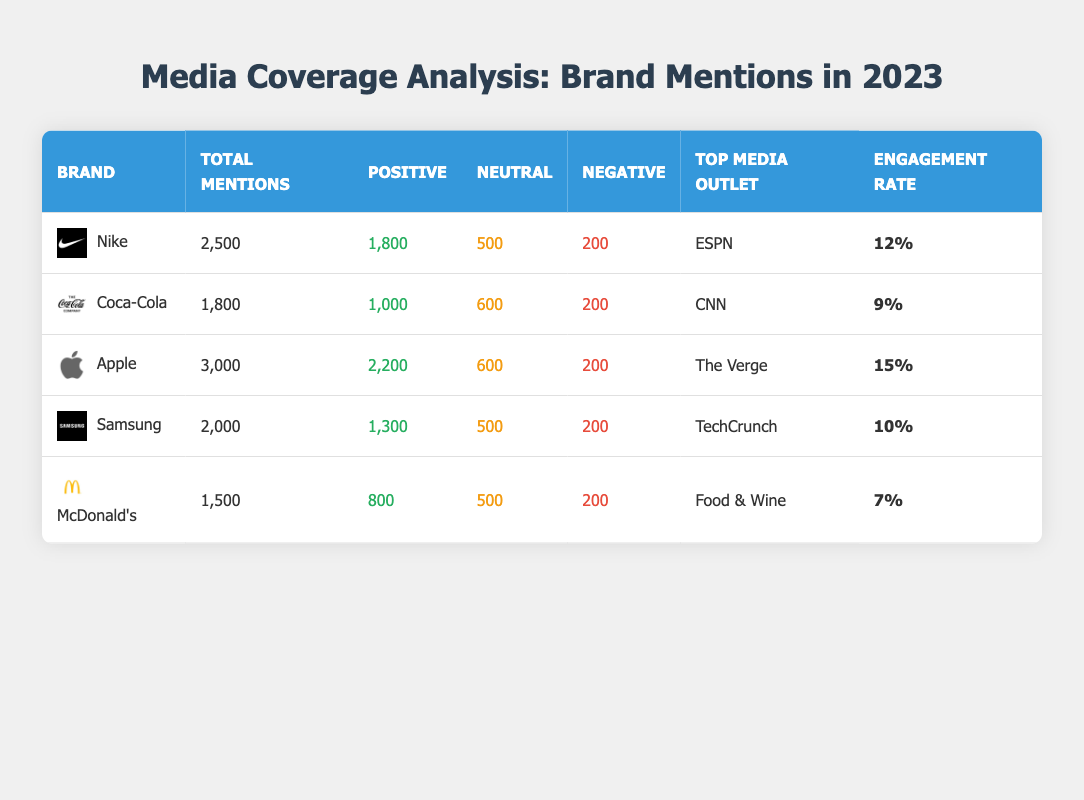What is the total number of mentions for Apple? In the table, under the "Total Mentions" column for Apple, the value listed is 3,000.
Answer: 3,000 Which brand received the highest engagement rate? The engagement rate is highest for Apple at 15%, which is greater than other brands listed.
Answer: Apple What is the difference between positive mentions and negative mentions for Nike? For Nike, positive mentions are 1,800 and negative mentions are 200. The difference is calculated as 1,800 - 200 = 1,600.
Answer: 1,600 Did Coca-Cola have more positive mentions than McDonald's in 2023? Coca-Cola had 1,000 positive mentions while McDonald's had 800 positive mentions. Since 1,000 is greater than 800, the answer is yes.
Answer: Yes What is the total number of neutral mentions for all brands combined? The total neutral mentions can be calculated by adding the neutral mentions from all brands: 500 (Nike) + 600 (Coca-Cola) + 600 (Apple) + 500 (Samsung) + 500 (McDonald's) = 2,400.
Answer: 2,400 Which media outlet was top for Samsung? The top media outlet for Samsung is TechCrunch, as listed in the "Top Media Outlet" column.
Answer: TechCrunch How many brands had negative mentions equal to 200? From the table, Nike, Coca-Cola, Apple, Samsung, and McDonald's each have negative mentions of 200. There are 5 brands with this number.
Answer: 5 What is the average engagement rate of all the brands? The engagement rates for the brands are 12%, 9%, 15%, 10%, and 7%. To calculate the average, add them: 12 + 9 + 15 + 10 + 7 = 53 and then divide by 5 which is 53 / 5 = 10.6%.
Answer: 10.6% Which brand had the least total mentions? McDonald's had the least total mentions, with a value of 1,500 under the "Total Mentions" column, which is lower than all other brands.
Answer: McDonald's 